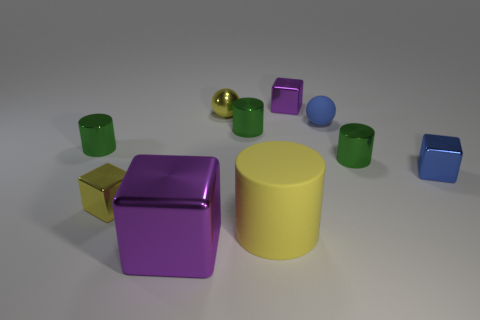How many shiny cubes have the same color as the tiny rubber ball?
Offer a very short reply. 1. There is a shiny cylinder on the right side of the big matte thing; what is its size?
Provide a short and direct response. Small. There is a purple metal thing that is behind the rubber object in front of the shiny block to the right of the tiny blue rubber sphere; what shape is it?
Keep it short and to the point. Cube. There is a metal object that is behind the big yellow matte thing and in front of the small blue metallic block; what is its shape?
Give a very brief answer. Cube. Are there any gray balls of the same size as the blue metal cube?
Your answer should be very brief. No. There is a small yellow metallic object that is behind the tiny matte thing; is its shape the same as the large matte object?
Your response must be concise. No. Do the big metallic thing and the blue matte object have the same shape?
Offer a very short reply. No. Is there a big matte object of the same shape as the small blue metal thing?
Your answer should be compact. No. What shape is the purple object on the left side of the block that is behind the small shiny ball?
Give a very brief answer. Cube. There is a rubber thing that is in front of the small blue shiny thing; what is its color?
Offer a terse response. Yellow. 